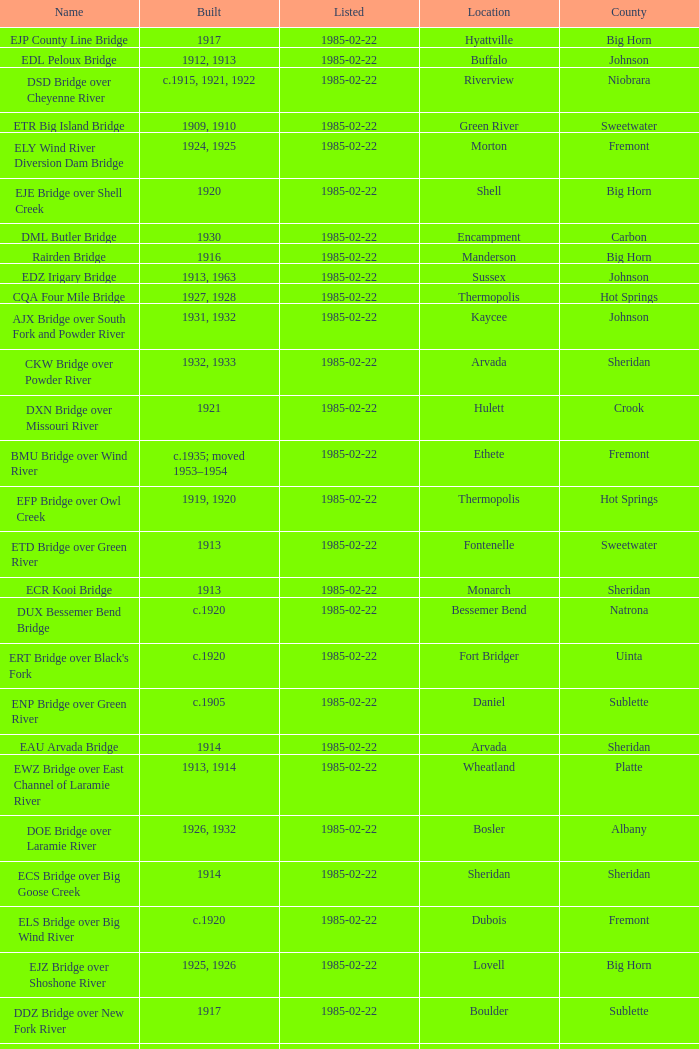What is the county of the bridge in Boulder? Sublette. Could you parse the entire table as a dict? {'header': ['Name', 'Built', 'Listed', 'Location', 'County'], 'rows': [['EJP County Line Bridge', '1917', '1985-02-22', 'Hyattville', 'Big Horn'], ['EDL Peloux Bridge', '1912, 1913', '1985-02-22', 'Buffalo', 'Johnson'], ['DSD Bridge over Cheyenne River', 'c.1915, 1921, 1922', '1985-02-22', 'Riverview', 'Niobrara'], ['ETR Big Island Bridge', '1909, 1910', '1985-02-22', 'Green River', 'Sweetwater'], ['ELY Wind River Diversion Dam Bridge', '1924, 1925', '1985-02-22', 'Morton', 'Fremont'], ['EJE Bridge over Shell Creek', '1920', '1985-02-22', 'Shell', 'Big Horn'], ['DML Butler Bridge', '1930', '1985-02-22', 'Encampment', 'Carbon'], ['Rairden Bridge', '1916', '1985-02-22', 'Manderson', 'Big Horn'], ['EDZ Irigary Bridge', '1913, 1963', '1985-02-22', 'Sussex', 'Johnson'], ['CQA Four Mile Bridge', '1927, 1928', '1985-02-22', 'Thermopolis', 'Hot Springs'], ['AJX Bridge over South Fork and Powder River', '1931, 1932', '1985-02-22', 'Kaycee', 'Johnson'], ['CKW Bridge over Powder River', '1932, 1933', '1985-02-22', 'Arvada', 'Sheridan'], ['DXN Bridge over Missouri River', '1921', '1985-02-22', 'Hulett', 'Crook'], ['BMU Bridge over Wind River', 'c.1935; moved 1953–1954', '1985-02-22', 'Ethete', 'Fremont'], ['EFP Bridge over Owl Creek', '1919, 1920', '1985-02-22', 'Thermopolis', 'Hot Springs'], ['ETD Bridge over Green River', '1913', '1985-02-22', 'Fontenelle', 'Sweetwater'], ['ECR Kooi Bridge', '1913', '1985-02-22', 'Monarch', 'Sheridan'], ['DUX Bessemer Bend Bridge', 'c.1920', '1985-02-22', 'Bessemer Bend', 'Natrona'], ["ERT Bridge over Black's Fork", 'c.1920', '1985-02-22', 'Fort Bridger', 'Uinta'], ['ENP Bridge over Green River', 'c.1905', '1985-02-22', 'Daniel', 'Sublette'], ['EAU Arvada Bridge', '1914', '1985-02-22', 'Arvada', 'Sheridan'], ['EWZ Bridge over East Channel of Laramie River', '1913, 1914', '1985-02-22', 'Wheatland', 'Platte'], ['DOE Bridge over Laramie River', '1926, 1932', '1985-02-22', 'Bosler', 'Albany'], ['ECS Bridge over Big Goose Creek', '1914', '1985-02-22', 'Sheridan', 'Sheridan'], ['ELS Bridge over Big Wind River', 'c.1920', '1985-02-22', 'Dubois', 'Fremont'], ['EJZ Bridge over Shoshone River', '1925, 1926', '1985-02-22', 'Lovell', 'Big Horn'], ['DDZ Bridge over New Fork River', '1917', '1985-02-22', 'Boulder', 'Sublette'], ['Hayden Arch Bridge', '1924, 1925', '1985-02-22', 'Cody', 'Park'], ['EBF Bridge over Powder River', '1915', '1985-02-22', 'Leiter', 'Sheridan'], ['DMJ Pick Bridge', '1909, 1910, 1934', '1985-02-22', 'Saratoga', 'Carbon'], ['DFU Elk Mountain Bridge', '1923, 1924', '1985-02-22', 'Elk Mountain', 'Carbon']]} 